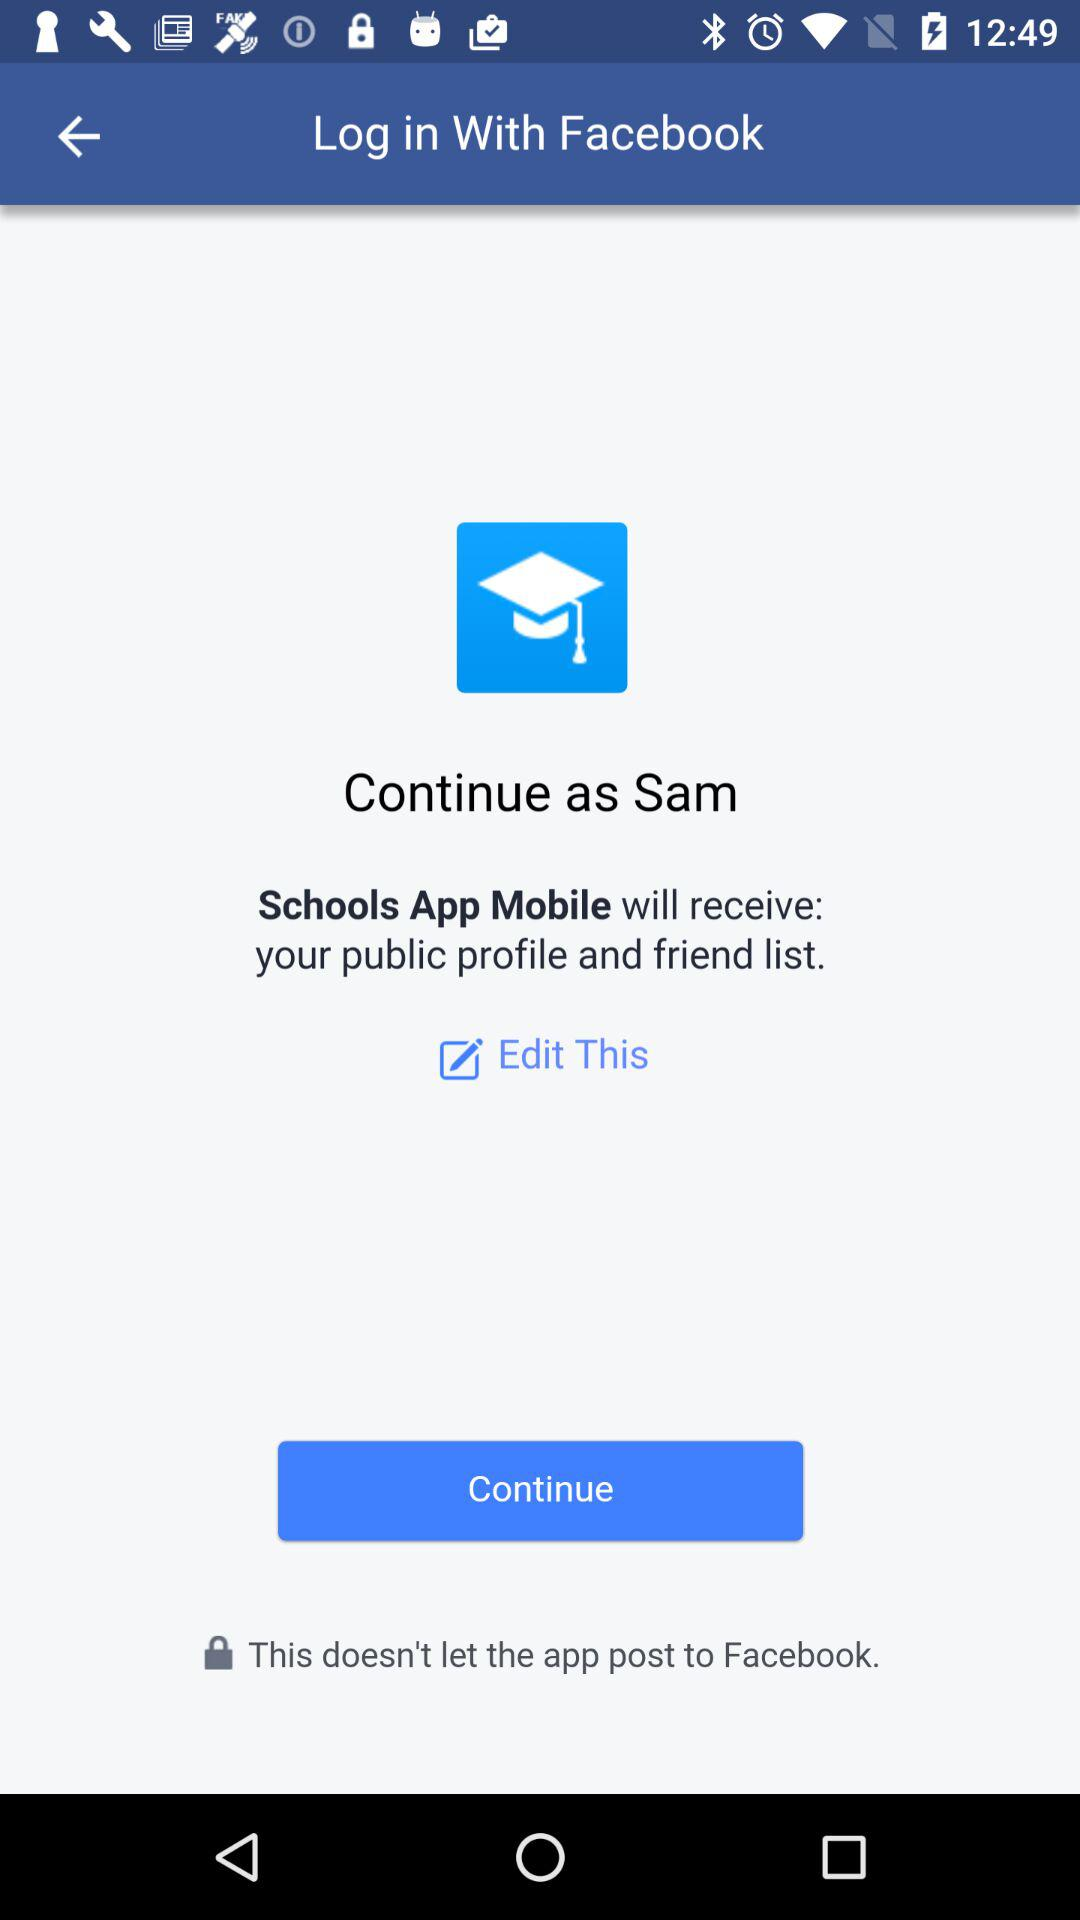What application will receive my public profile and friend list? The application that will receive your public profile and friend list is "Schools App Mobile". 